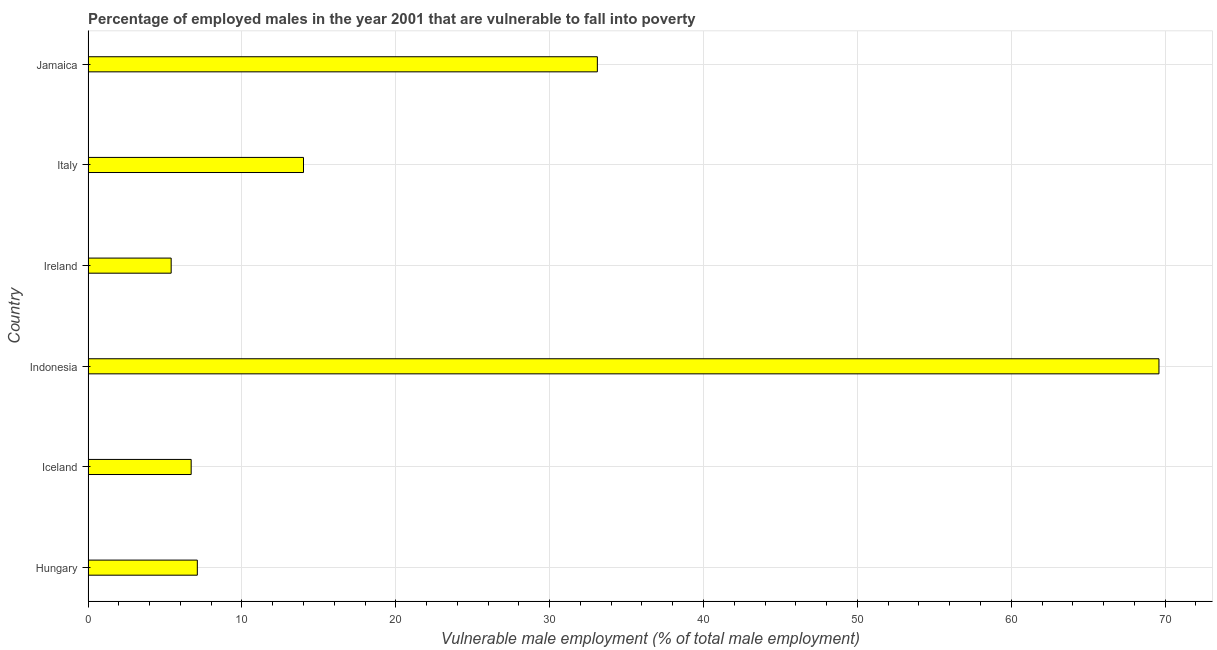Does the graph contain any zero values?
Ensure brevity in your answer.  No. What is the title of the graph?
Make the answer very short. Percentage of employed males in the year 2001 that are vulnerable to fall into poverty. What is the label or title of the X-axis?
Provide a short and direct response. Vulnerable male employment (% of total male employment). What is the label or title of the Y-axis?
Provide a succinct answer. Country. What is the percentage of employed males who are vulnerable to fall into poverty in Iceland?
Your response must be concise. 6.7. Across all countries, what is the maximum percentage of employed males who are vulnerable to fall into poverty?
Provide a succinct answer. 69.6. Across all countries, what is the minimum percentage of employed males who are vulnerable to fall into poverty?
Give a very brief answer. 5.4. In which country was the percentage of employed males who are vulnerable to fall into poverty maximum?
Give a very brief answer. Indonesia. In which country was the percentage of employed males who are vulnerable to fall into poverty minimum?
Your answer should be very brief. Ireland. What is the sum of the percentage of employed males who are vulnerable to fall into poverty?
Your answer should be compact. 135.9. What is the average percentage of employed males who are vulnerable to fall into poverty per country?
Keep it short and to the point. 22.65. What is the median percentage of employed males who are vulnerable to fall into poverty?
Your response must be concise. 10.55. In how many countries, is the percentage of employed males who are vulnerable to fall into poverty greater than 2 %?
Offer a very short reply. 6. What is the ratio of the percentage of employed males who are vulnerable to fall into poverty in Indonesia to that in Jamaica?
Ensure brevity in your answer.  2.1. Is the percentage of employed males who are vulnerable to fall into poverty in Iceland less than that in Indonesia?
Your answer should be very brief. Yes. Is the difference between the percentage of employed males who are vulnerable to fall into poverty in Ireland and Italy greater than the difference between any two countries?
Give a very brief answer. No. What is the difference between the highest and the second highest percentage of employed males who are vulnerable to fall into poverty?
Provide a short and direct response. 36.5. Is the sum of the percentage of employed males who are vulnerable to fall into poverty in Hungary and Jamaica greater than the maximum percentage of employed males who are vulnerable to fall into poverty across all countries?
Offer a terse response. No. What is the difference between the highest and the lowest percentage of employed males who are vulnerable to fall into poverty?
Make the answer very short. 64.2. In how many countries, is the percentage of employed males who are vulnerable to fall into poverty greater than the average percentage of employed males who are vulnerable to fall into poverty taken over all countries?
Your answer should be compact. 2. What is the Vulnerable male employment (% of total male employment) of Hungary?
Keep it short and to the point. 7.1. What is the Vulnerable male employment (% of total male employment) of Iceland?
Keep it short and to the point. 6.7. What is the Vulnerable male employment (% of total male employment) of Indonesia?
Your answer should be compact. 69.6. What is the Vulnerable male employment (% of total male employment) of Ireland?
Make the answer very short. 5.4. What is the Vulnerable male employment (% of total male employment) in Jamaica?
Ensure brevity in your answer.  33.1. What is the difference between the Vulnerable male employment (% of total male employment) in Hungary and Indonesia?
Offer a very short reply. -62.5. What is the difference between the Vulnerable male employment (% of total male employment) in Iceland and Indonesia?
Your answer should be compact. -62.9. What is the difference between the Vulnerable male employment (% of total male employment) in Iceland and Ireland?
Ensure brevity in your answer.  1.3. What is the difference between the Vulnerable male employment (% of total male employment) in Iceland and Italy?
Your answer should be very brief. -7.3. What is the difference between the Vulnerable male employment (% of total male employment) in Iceland and Jamaica?
Offer a terse response. -26.4. What is the difference between the Vulnerable male employment (% of total male employment) in Indonesia and Ireland?
Offer a very short reply. 64.2. What is the difference between the Vulnerable male employment (% of total male employment) in Indonesia and Italy?
Keep it short and to the point. 55.6. What is the difference between the Vulnerable male employment (% of total male employment) in Indonesia and Jamaica?
Ensure brevity in your answer.  36.5. What is the difference between the Vulnerable male employment (% of total male employment) in Ireland and Italy?
Provide a short and direct response. -8.6. What is the difference between the Vulnerable male employment (% of total male employment) in Ireland and Jamaica?
Your answer should be compact. -27.7. What is the difference between the Vulnerable male employment (% of total male employment) in Italy and Jamaica?
Your answer should be very brief. -19.1. What is the ratio of the Vulnerable male employment (% of total male employment) in Hungary to that in Iceland?
Offer a very short reply. 1.06. What is the ratio of the Vulnerable male employment (% of total male employment) in Hungary to that in Indonesia?
Your answer should be compact. 0.1. What is the ratio of the Vulnerable male employment (% of total male employment) in Hungary to that in Ireland?
Provide a succinct answer. 1.31. What is the ratio of the Vulnerable male employment (% of total male employment) in Hungary to that in Italy?
Offer a terse response. 0.51. What is the ratio of the Vulnerable male employment (% of total male employment) in Hungary to that in Jamaica?
Your response must be concise. 0.21. What is the ratio of the Vulnerable male employment (% of total male employment) in Iceland to that in Indonesia?
Provide a succinct answer. 0.1. What is the ratio of the Vulnerable male employment (% of total male employment) in Iceland to that in Ireland?
Offer a terse response. 1.24. What is the ratio of the Vulnerable male employment (% of total male employment) in Iceland to that in Italy?
Your response must be concise. 0.48. What is the ratio of the Vulnerable male employment (% of total male employment) in Iceland to that in Jamaica?
Your answer should be compact. 0.2. What is the ratio of the Vulnerable male employment (% of total male employment) in Indonesia to that in Ireland?
Provide a succinct answer. 12.89. What is the ratio of the Vulnerable male employment (% of total male employment) in Indonesia to that in Italy?
Provide a short and direct response. 4.97. What is the ratio of the Vulnerable male employment (% of total male employment) in Indonesia to that in Jamaica?
Your response must be concise. 2.1. What is the ratio of the Vulnerable male employment (% of total male employment) in Ireland to that in Italy?
Your answer should be compact. 0.39. What is the ratio of the Vulnerable male employment (% of total male employment) in Ireland to that in Jamaica?
Your response must be concise. 0.16. What is the ratio of the Vulnerable male employment (% of total male employment) in Italy to that in Jamaica?
Your answer should be compact. 0.42. 